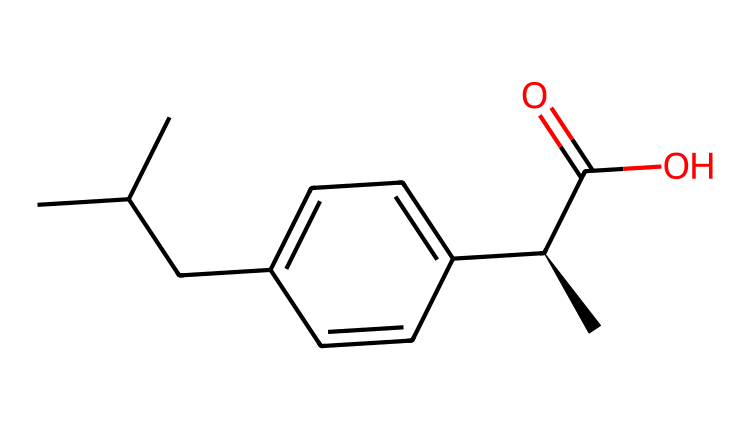What is the IUPAC name of this compound? The provided SMILES representation corresponds to the structure of S-ibuprofen, which is the active form of the over-the-counter painkiller. The IUPAC name highlights the stereochemistry as 'S' indicating the specific chiral configuration.
Answer: S-ibuprofen How many stereocenters are present in this compound? The SMILES notation includes the '@' symbol indicating the presence of a chiral carbon atom. Upon examining the structure, there is one stereocenter located in the carbon with the '@' symbol, confirming its chirality.
Answer: 1 What functional group is present in S-ibuprofen? Within the structure of S-ibuprofen, you can identify a carboxylic acid functional group, which is denoted by the presence of a carbon atom double-bonded to an oxygen atom as well as single-bonded to a hydroxyl group (-COOH).
Answer: carboxylic acid What type of compound is S-ibuprofen primarily classified as? S-ibuprofen is classified as a chiral compound and also as a pharmaceutical drug. This classification comes from its molecular structure containing a chiral center that leads to specific biological activity.
Answer: chiral compound What is the total number of carbon atoms in S-ibuprofen? By analyzing the SMILES representation, we can count the number of 'C' characters. There are a total of 13 carbon atoms present in the structure of S-ibuprofen.
Answer: 13 